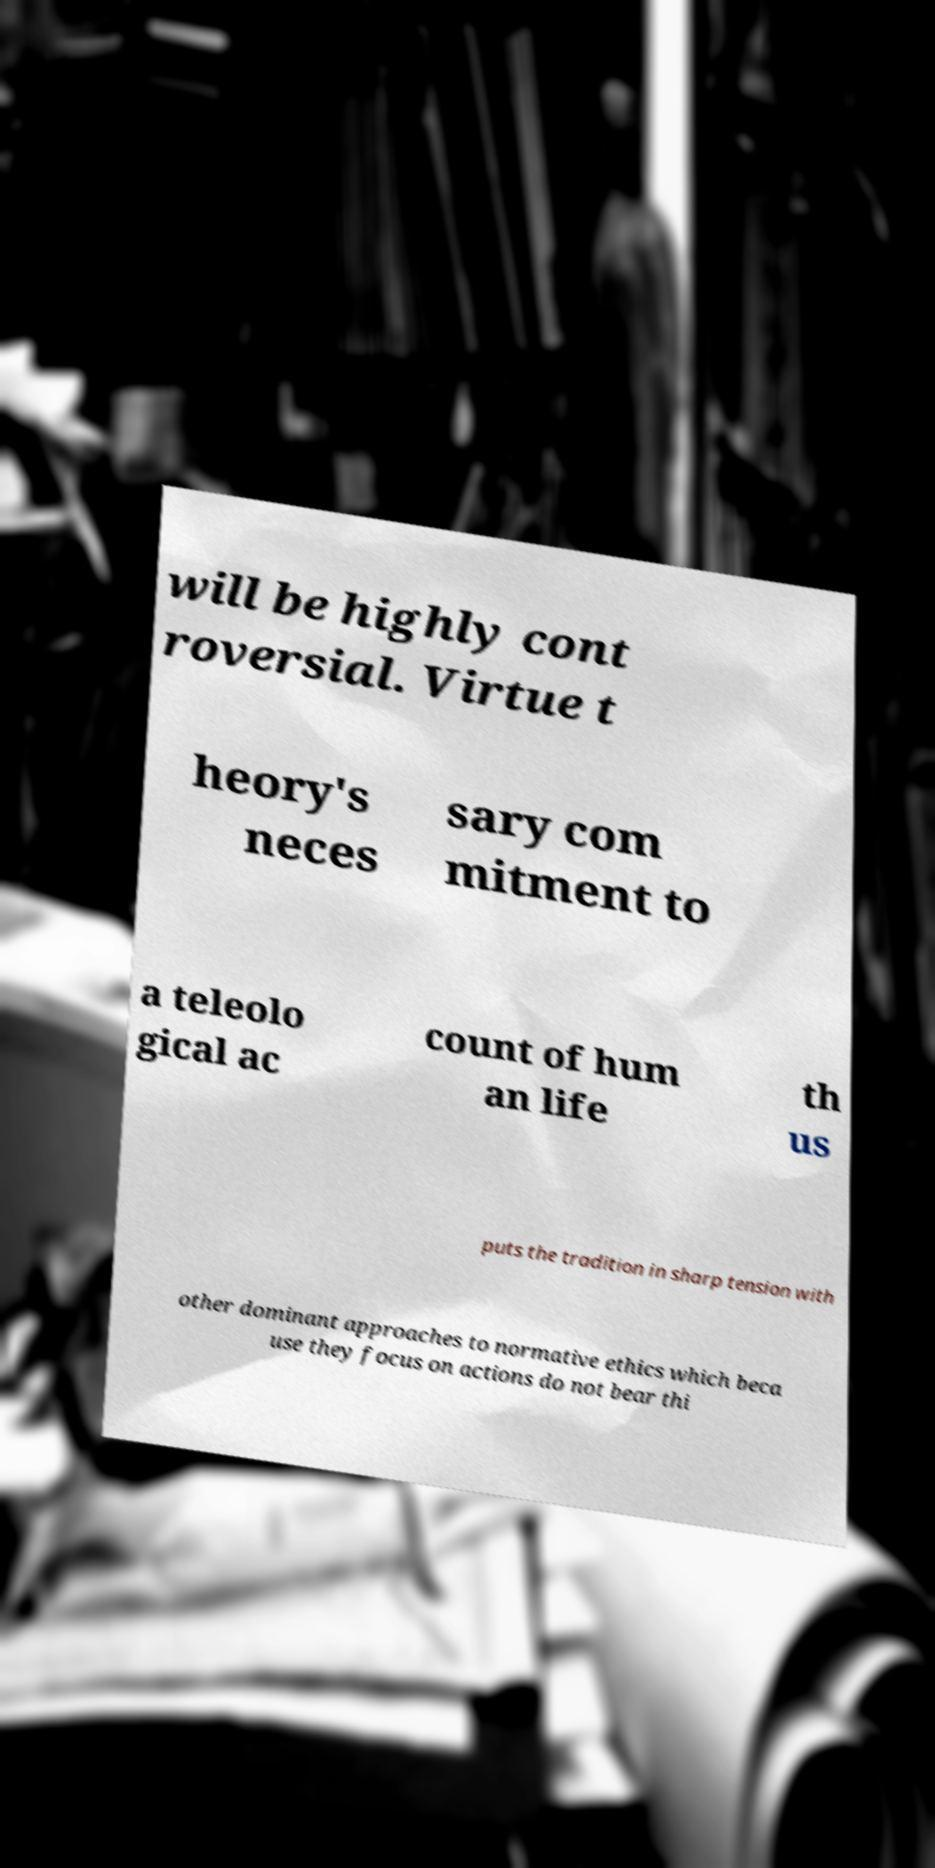Could you extract and type out the text from this image? will be highly cont roversial. Virtue t heory's neces sary com mitment to a teleolo gical ac count of hum an life th us puts the tradition in sharp tension with other dominant approaches to normative ethics which beca use they focus on actions do not bear thi 